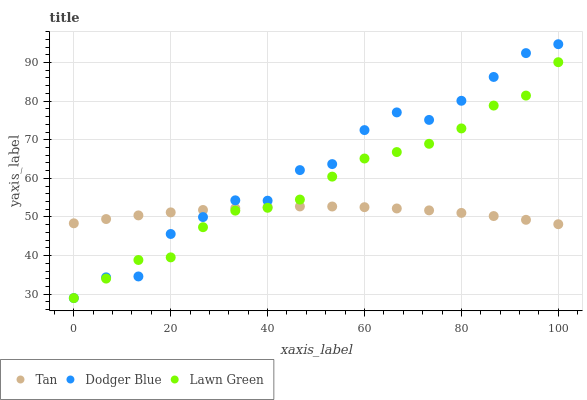Does Tan have the minimum area under the curve?
Answer yes or no. Yes. Does Dodger Blue have the maximum area under the curve?
Answer yes or no. Yes. Does Dodger Blue have the minimum area under the curve?
Answer yes or no. No. Does Tan have the maximum area under the curve?
Answer yes or no. No. Is Tan the smoothest?
Answer yes or no. Yes. Is Dodger Blue the roughest?
Answer yes or no. Yes. Is Dodger Blue the smoothest?
Answer yes or no. No. Is Tan the roughest?
Answer yes or no. No. Does Lawn Green have the lowest value?
Answer yes or no. Yes. Does Tan have the lowest value?
Answer yes or no. No. Does Dodger Blue have the highest value?
Answer yes or no. Yes. Does Tan have the highest value?
Answer yes or no. No. Does Dodger Blue intersect Lawn Green?
Answer yes or no. Yes. Is Dodger Blue less than Lawn Green?
Answer yes or no. No. Is Dodger Blue greater than Lawn Green?
Answer yes or no. No. 